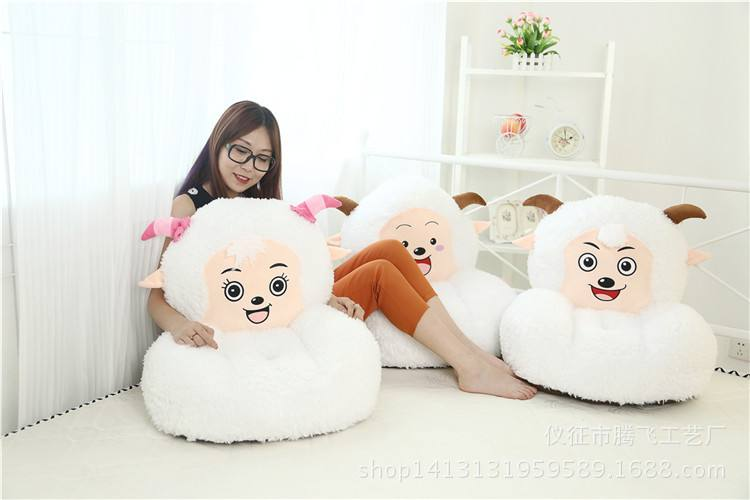How many sofas are there in the image? In the image, there are three adorable sheep-themed sofas, each uniquely designed with a happy facial expression, adding a playful and whimsical touch to the room. 